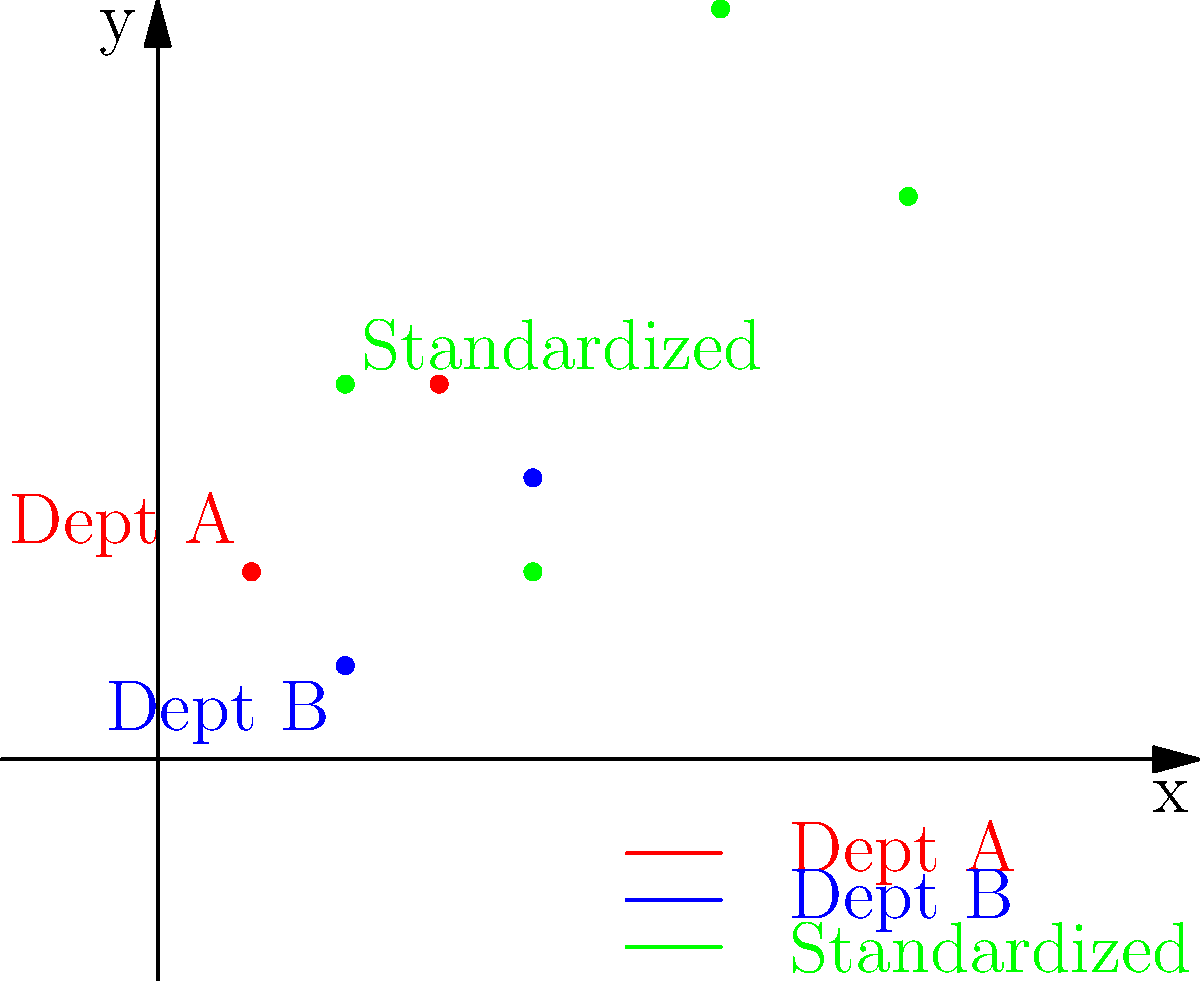As a retired government auditor, you're tasked with standardizing data from two different departments. Department A reports coordinates in the standard (x, y) format, while Department B reports them as (y, x). The transformation matrix to standardize Department B's data is given by:

$$
T = \begin{bmatrix}
0 & 1 \\
1 & 0
\end{bmatrix}
$$

After applying this transformation and doubling all coordinates, what will be the standardized coordinates for the point originally reported by Department B as (1, 2)? Let's approach this step-by-step:

1) First, we need to apply the transformation matrix to Department B's point (1, 2):

   $$\begin{bmatrix}
   0 & 1 \\
   1 & 0
   \end{bmatrix} \begin{bmatrix}
   1 \\
   2
   \end{bmatrix} = \begin{bmatrix}
   2 \\
   1
   \end{bmatrix}$$

2) This switches the x and y coordinates, giving us (2, 1).

3) Now, we need to double all coordinates:

   $$(2, 1) \rightarrow (2 * 2, 1 * 2) = (4, 2)$$

4) Therefore, the final standardized coordinates are (4, 2).

In the graph, you can see the original points from both departments in red and blue, and the standardized points in green. The point we calculated is one of these green points.
Answer: (4, 2) 